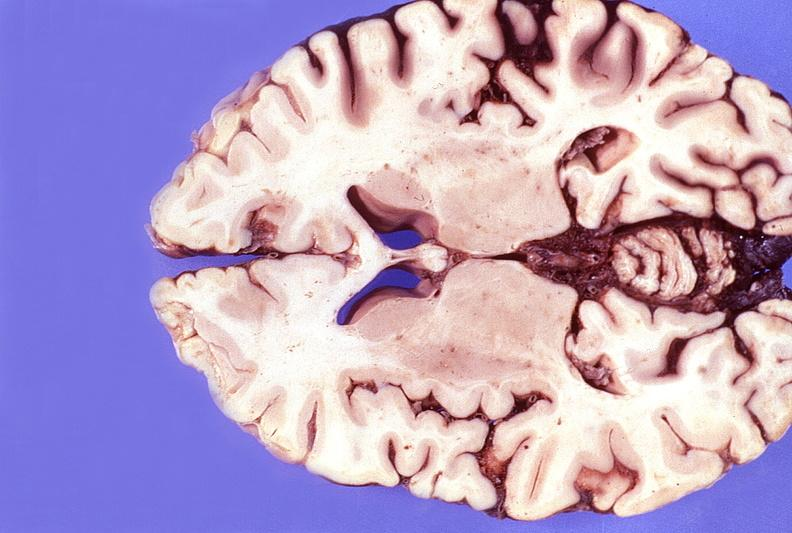what is present?
Answer the question using a single word or phrase. Nervous 